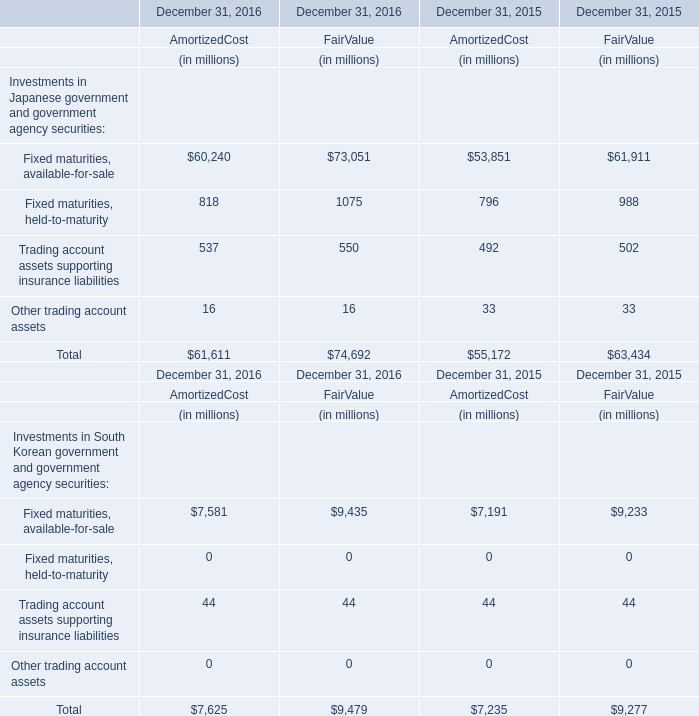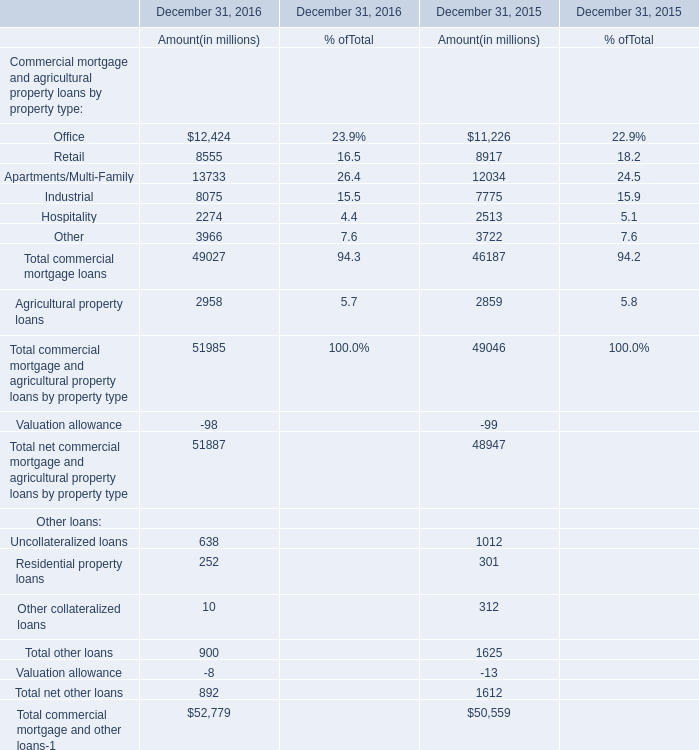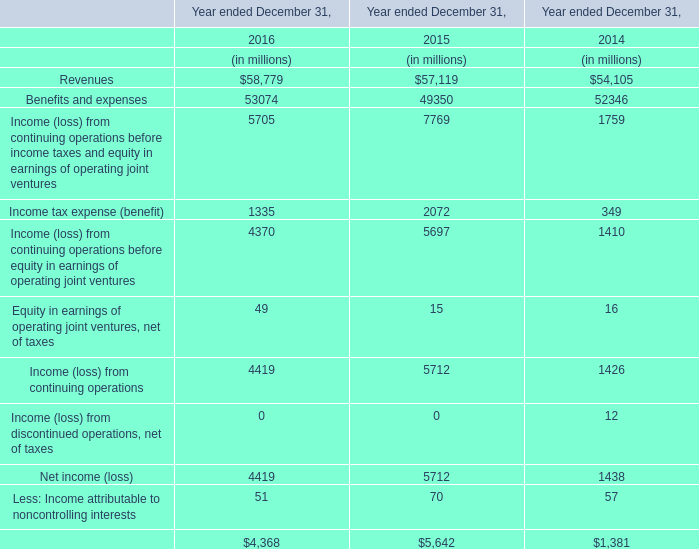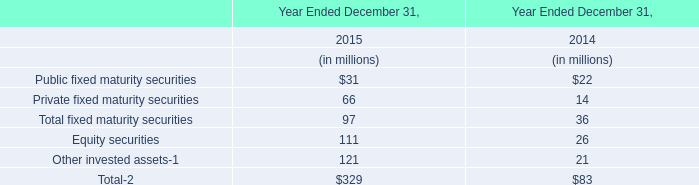In the year with the most Fixed maturities, available-for-sale, what is the growth rate of Trading account assets supporting insurance liabilities? 
Computations: ((((537 + 550) - 492) - 502) / (537 + 550))
Answer: 0.08556. 